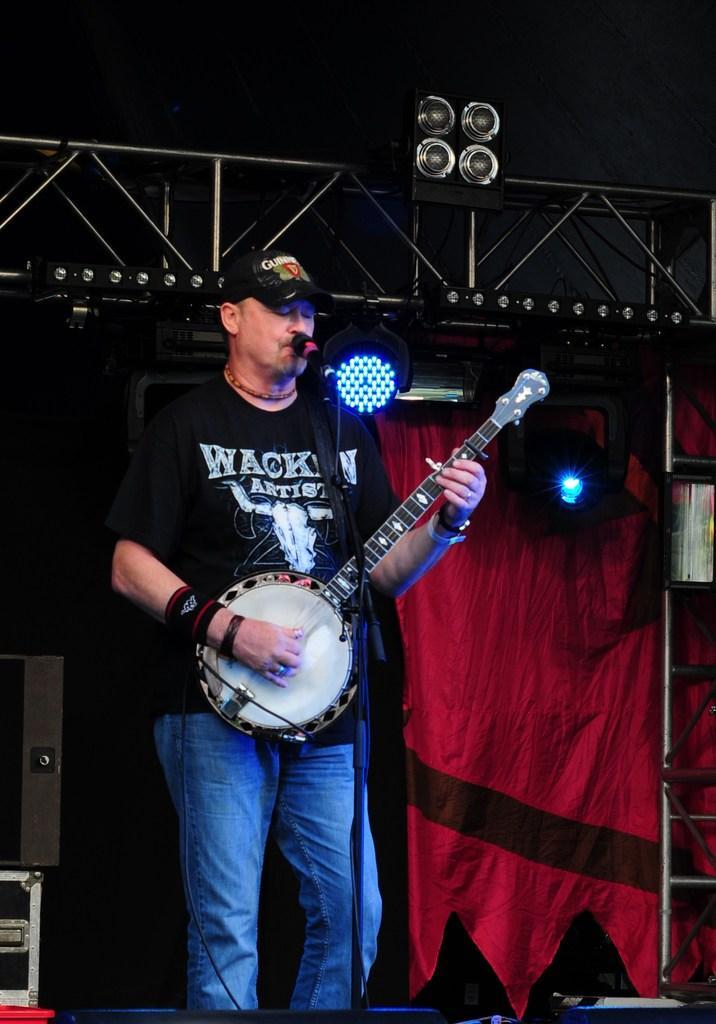Please provide a concise description of this image. In this image there is a person playing a musical instrument in front of the mic, behind the person there are lights, metal rods, curtains and some other equipment. 